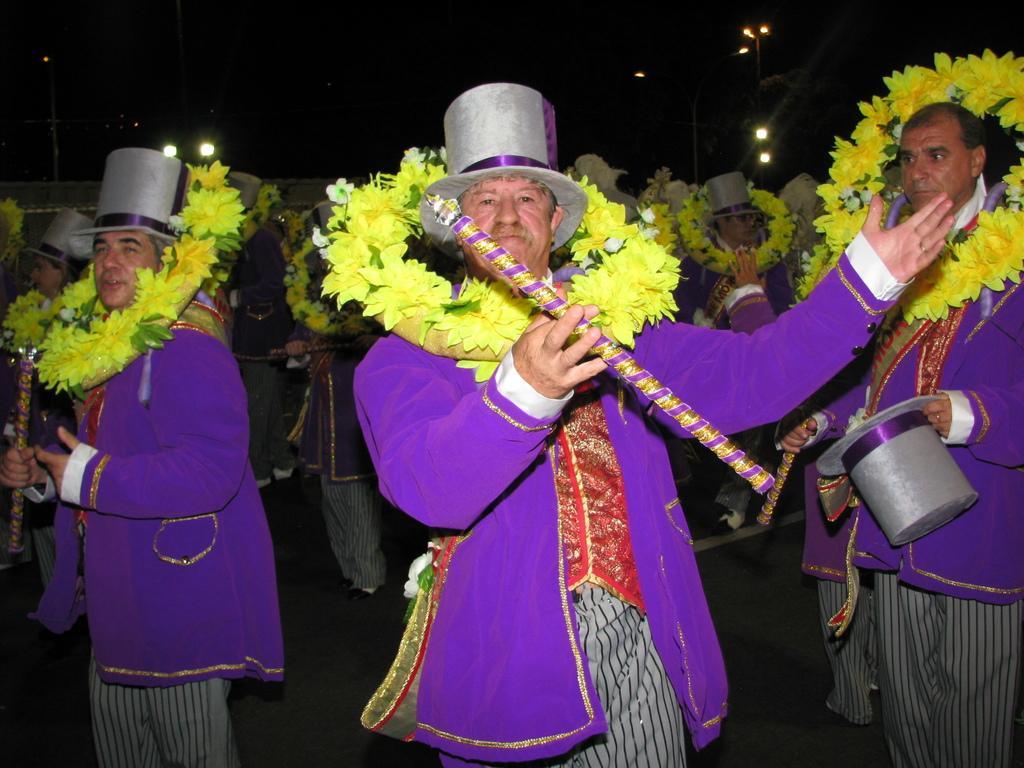How would you summarize this image in a sentence or two? In the image there are few men in purple jackets in garland and hats holding flutes, In the back there are lights. 